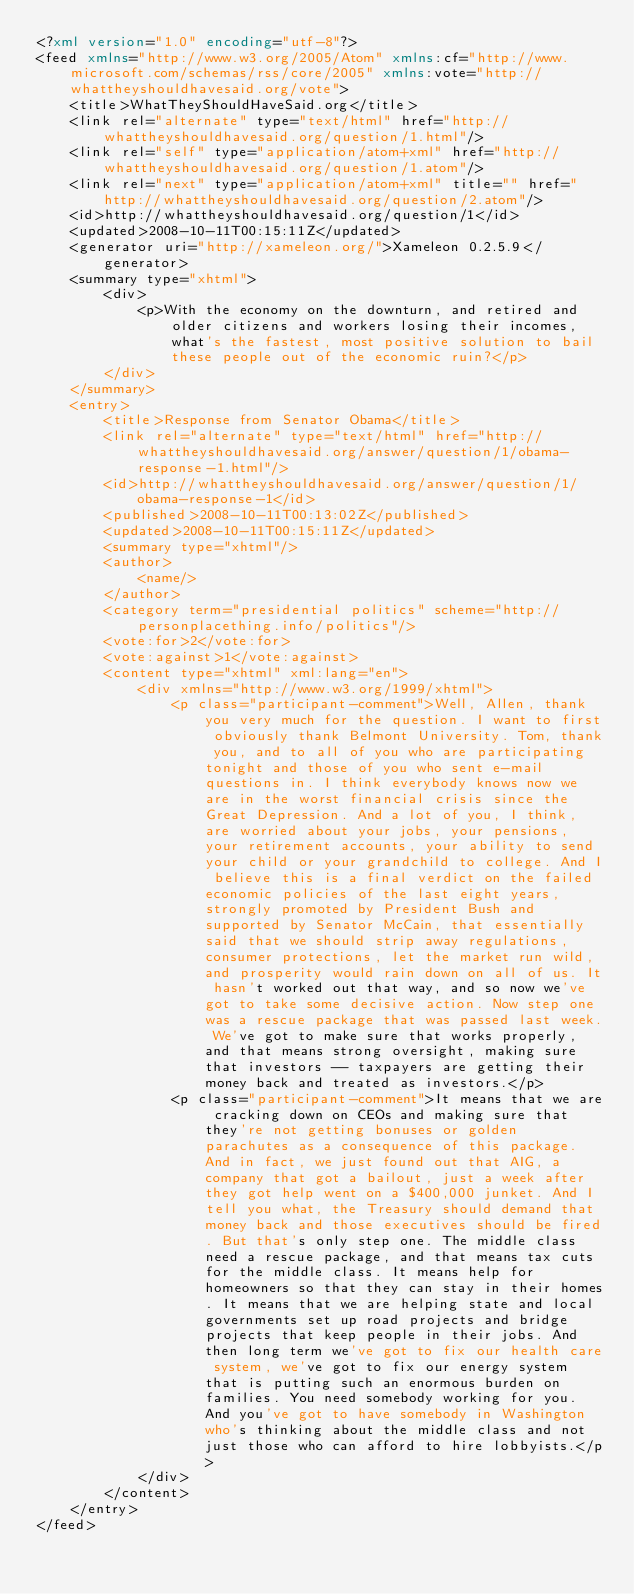Convert code to text. <code><loc_0><loc_0><loc_500><loc_500><_XML_><?xml version="1.0" encoding="utf-8"?>
<feed xmlns="http://www.w3.org/2005/Atom" xmlns:cf="http://www.microsoft.com/schemas/rss/core/2005" xmlns:vote="http://whattheyshouldhavesaid.org/vote">
	<title>WhatTheyShouldHaveSaid.org</title>
	<link rel="alternate" type="text/html" href="http://whattheyshouldhavesaid.org/question/1.html"/>
	<link rel="self" type="application/atom+xml" href="http://whattheyshouldhavesaid.org/question/1.atom"/>
	<link rel="next" type="application/atom+xml" title="" href="http://whattheyshouldhavesaid.org/question/2.atom"/>
	<id>http://whattheyshouldhavesaid.org/question/1</id>
	<updated>2008-10-11T00:15:11Z</updated>
	<generator uri="http://xameleon.org/">Xameleon 0.2.5.9</generator>
	<summary type="xhtml">
		<div>
			<p>With the economy on the downturn, and retired and older citizens and workers losing their incomes, what's the fastest, most positive solution to bail these people out of the economic ruin?</p>
		</div>
	</summary>
	<entry>
		<title>Response from Senator Obama</title>
		<link rel="alternate" type="text/html" href="http://whattheyshouldhavesaid.org/answer/question/1/obama-response-1.html"/>
		<id>http://whattheyshouldhavesaid.org/answer/question/1/obama-response-1</id>
		<published>2008-10-11T00:13:02Z</published>
		<updated>2008-10-11T00:15:11Z</updated>
		<summary type="xhtml"/>
		<author>
			<name/>
		</author>
		<category term="presidential politics" scheme="http://personplacething.info/politics"/>
		<vote:for>2</vote:for>
		<vote:against>1</vote:against>
		<content type="xhtml" xml:lang="en">
			<div xmlns="http://www.w3.org/1999/xhtml">
				<p class="participant-comment">Well, Allen, thank you very much for the question. I want to first obviously thank Belmont University. Tom, thank you, and to all of you who are participating tonight and those of you who sent e-mail questions in. I think everybody knows now we are in the worst financial crisis since the Great Depression. And a lot of you, I think, are worried about your jobs, your pensions, your retirement accounts, your ability to send your child or your grandchild to college. And I believe this is a final verdict on the failed economic policies of the last eight years, strongly promoted by President Bush and supported by Senator McCain, that essentially said that we should strip away regulations, consumer protections, let the market run wild, and prosperity would rain down on all of us. It hasn't worked out that way, and so now we've got to take some decisive action. Now step one was a rescue package that was passed last week. We've got to make sure that works properly, and that means strong oversight, making sure that investors -- taxpayers are getting their money back and treated as investors.</p>
				<p class="participant-comment">It means that we are cracking down on CEOs and making sure that they're not getting bonuses or golden parachutes as a consequence of this package. And in fact, we just found out that AIG, a company that got a bailout, just a week after they got help went on a $400,000 junket. And I tell you what, the Treasury should demand that money back and those executives should be fired. But that's only step one. The middle class need a rescue package, and that means tax cuts for the middle class. It means help for homeowners so that they can stay in their homes. It means that we are helping state and local governments set up road projects and bridge projects that keep people in their jobs. And then long term we've got to fix our health care system, we've got to fix our energy system that is putting such an enormous burden on families. You need somebody working for you. And you've got to have somebody in Washington who's thinking about the middle class and not just those who can afford to hire lobbyists.</p>
			</div>
		</content>
	</entry>
</feed>
</code> 